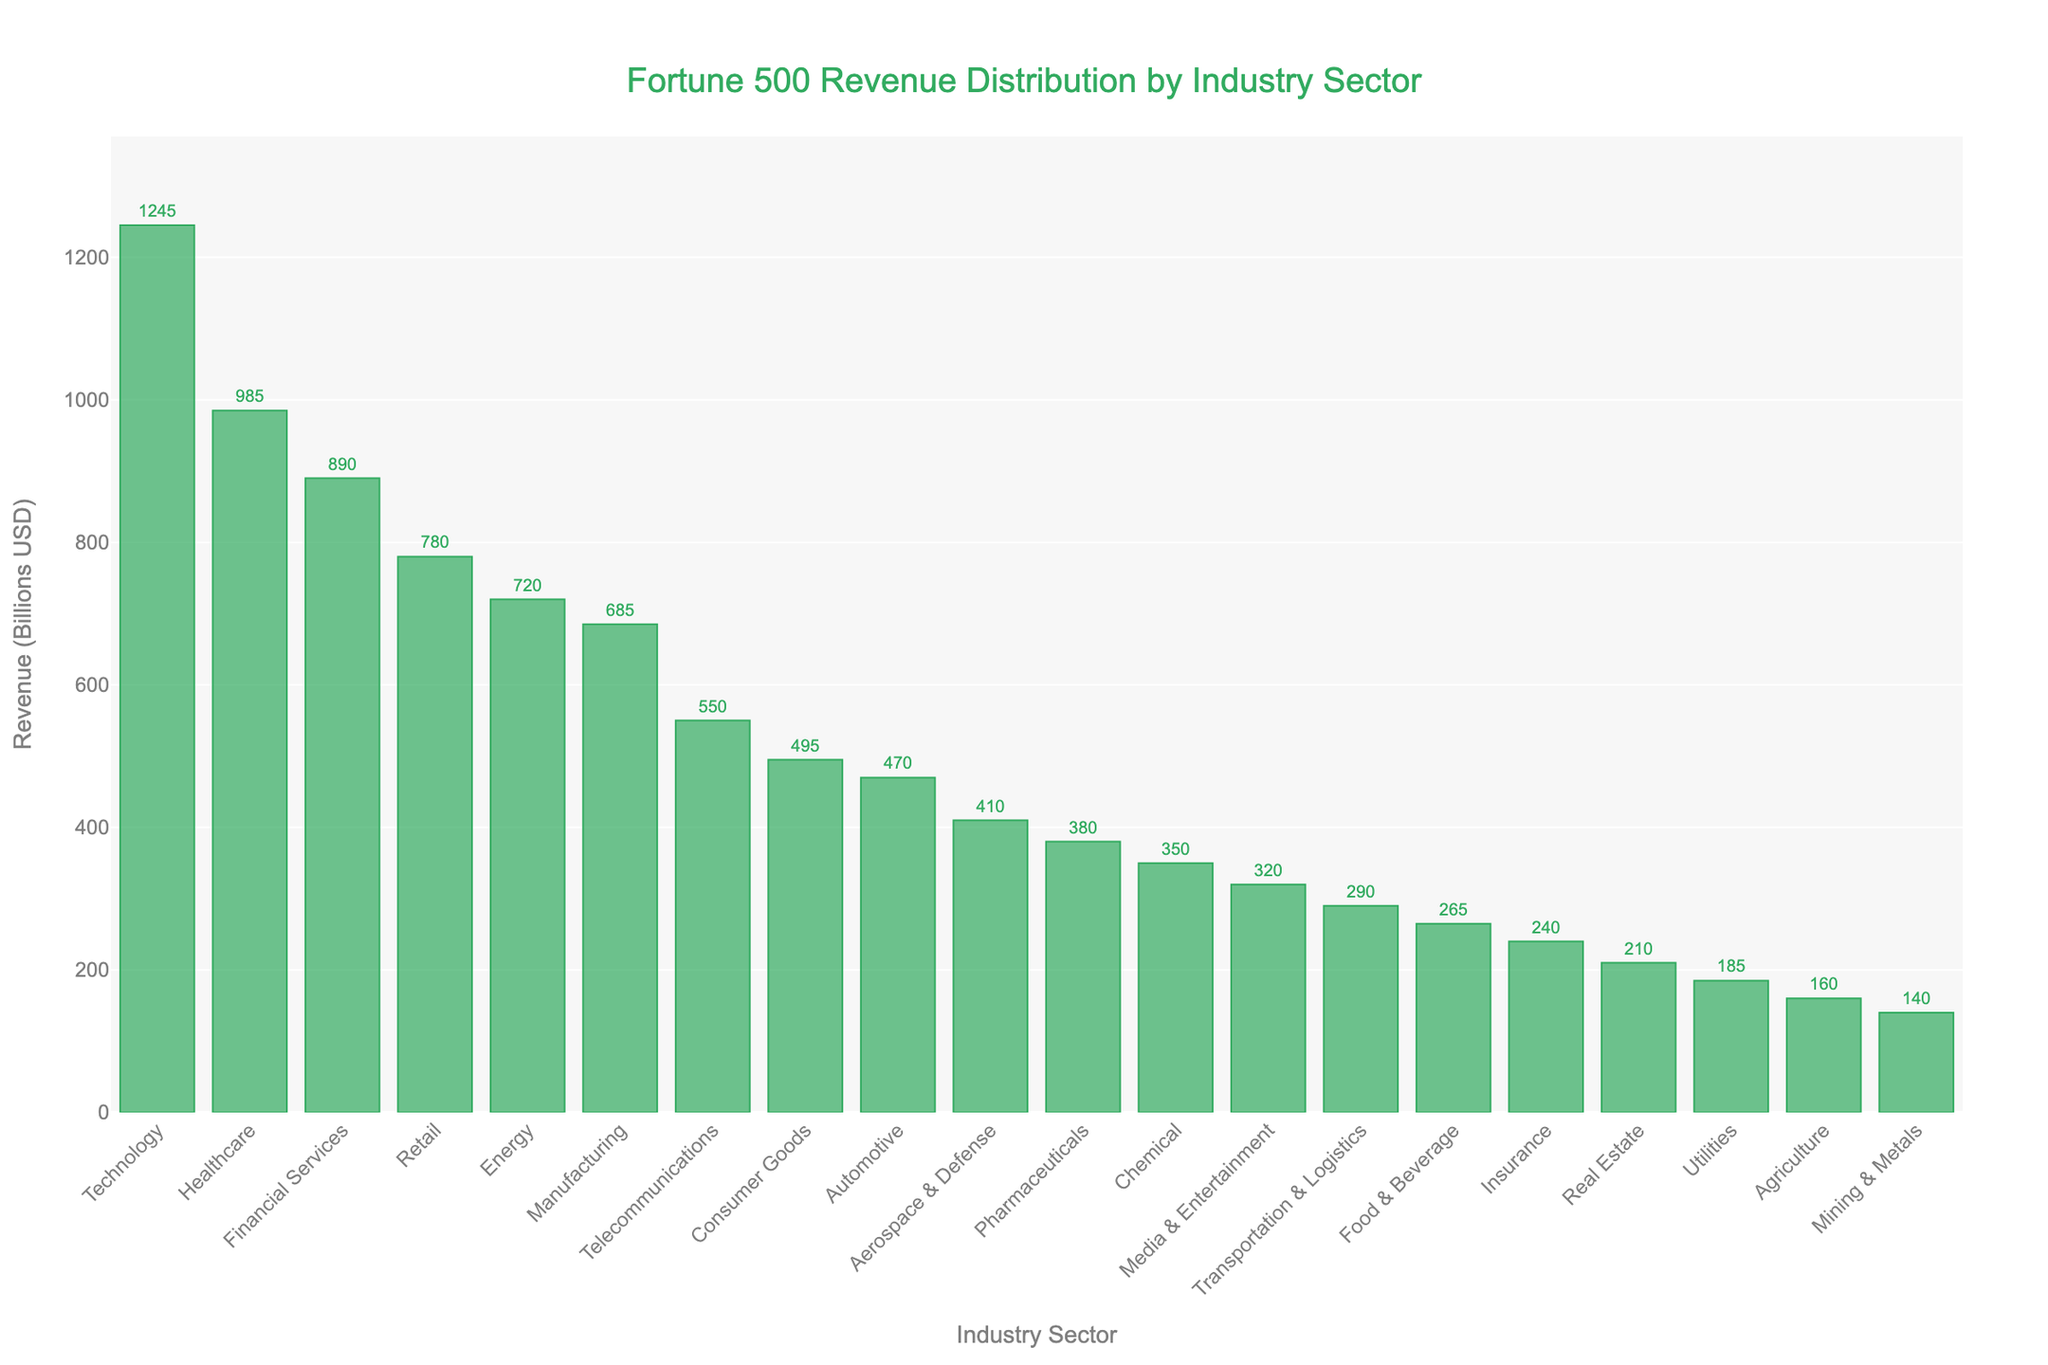Which industry sector has the highest revenue? The technology sector has the tallest bar in the chart, indicating the highest revenue among all industries.
Answer: Technology What is the total revenue for Technology and Healthcare sectors combined? The Technology sector has a revenue of 1245 billion USD, and the Healthcare sector has a revenue of 985 billion USD. Adding these together: 1245 + 985 = 2230 billion USD.
Answer: 2230 billion USD How does the revenue of the Financial Services sector compare to the Retail sector? The Financial Services sector has a revenue of 890 billion USD, while the Retail sector has a revenue of 780 billion USD. Therefore, Financial Services has a higher revenue.
Answer: Financial Services is higher Which sector has a lower revenue, Energy or Manufacturing, and by how much? The Energy sector has a revenue of 720 billion USD, and the Manufacturing sector has a revenue of 685 billion USD. The difference is: 720 - 685 = 35 billion USD. Therefore, Manufacturing has a lower revenue by 35 billion USD.
Answer: Manufacturing by 35 billion USD What is the sum of revenues for the Telecommunications, Consumer Goods, and Automotive sectors? The revenues are: Telecommunications (550 billion USD), Consumer Goods (495 billion USD), Automotive (470 billion USD). Adding these together: 550 + 495 + 470 = 1515 billion USD.
Answer: 1515 billion USD Is the revenue of the Pharmaceuticals sector higher or lower than that of the Aerospace & Defense sector? The Pharmaceuticals sector has a revenue of 380 billion USD while the Aerospace & Defense sector has a revenue of 410 billion USD. Therefore, the Pharmaceuticals sector's revenue is lower.
Answer: Lower What is the average revenue of the top five sectors? The top five sectors by revenue are Technology (1245 billion USD), Healthcare (985 billion USD), Financial Services (890 billion USD), Retail (780 billion USD), Energy (720 billion USD). The sum of these revenues is 1245 + 985 + 890 + 780 + 720 = 4620 billion USD. The average is 4620 / 5 = 924 billion USD.
Answer: 924 billion USD Which sector has a revenue closest to 300 billion USD? The Media & Entertainment sector has a revenue of 320 billion USD, which is the closest to 300 billion USD among all sectors.
Answer: Media & Entertainment Is the combined revenue of the Utilities and Agriculture sectors higher or lower than the revenue of the Automotive sector? Utilities' revenue is 185 billion USD and Agriculture's revenue is 160 billion USD. Their combined revenue is 185 + 160 = 345 billion USD. The Automotive sector has a revenue of 470 billion USD. Therefore, the combined revenue of Utilities and Agriculture is lower.
Answer: Lower What is the second-highest revenue sector, and what is its revenue? The sector with the second-highest revenue is Healthcare, with a revenue of 985 billion USD.
Answer: Healthcare, 985 billion USD 